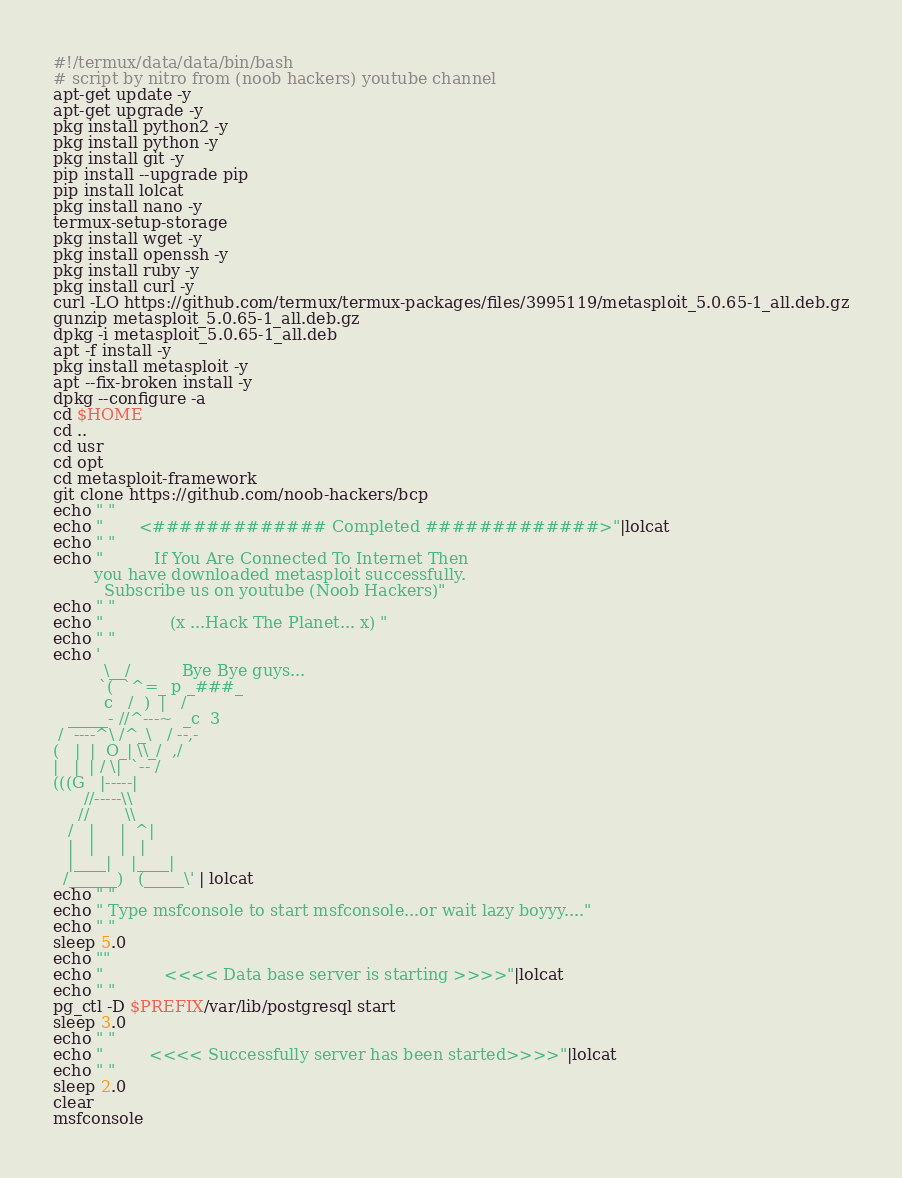<code> <loc_0><loc_0><loc_500><loc_500><_Bash_>#!/termux/data/data/bin/bash
# script by nitro from (noob hackers) youtube channel
apt-get update -y
apt-get upgrade -y
pkg install python2 -y
pkg install python -y
pkg install git -y
pip install --upgrade pip
pip install lolcat 
pkg install nano -y
termux-setup-storage
pkg install wget -y
pkg install openssh -y
pkg install ruby -y
pkg install curl -y
curl -LO https://github.com/termux/termux-packages/files/3995119/metasploit_5.0.65-1_all.deb.gz
gunzip metasploit_5.0.65-1_all.deb.gz
dpkg -i metasploit_5.0.65-1_all.deb 
apt -f install -y
pkg install metasploit -y
apt --fix-broken install -y
dpkg --configure -a
cd $HOME
cd ..
cd usr
cd opt
cd metasploit-framework
git clone https://github.com/noob-hackers/bcp
echo " "
echo "       <############# Completed #############>"|lolcat
echo " "
echo "          If You Are Connected To Internet Then
        you have downloaded metasploit successfully.
          Subscribe us on youtube (Noob Hackers)"
echo " "
echo "             (x ...Hack The Planet... x) "
echo " "
echo '
          \__/          Bye Bye guys...
         `(  `^=_ p _###_
          c   /  )  |   /
   _____- //^---~  _c  3
 /  ----^\ /^_\   / --,-
(   |  |  O_| \\_/  ,/
|   |  | / \|  `-- /
(((G   |-----|
      //-----\\
     //       \\
   /   |     |  ^|
   |   |     |   |
   |____|    |____|
  /______)   (_____\' | lolcat
echo " "
echo " Type msfconsole to start msfconsole...or wait lazy boyyy...."
echo " "
sleep 5.0
echo ""
echo "            <<<< Data base server is starting >>>>"|lolcat
echo " "
pg_ctl -D $PREFIX/var/lib/postgresql start
sleep 3.0
echo " "
echo "         <<<< Successfully server has been started>>>>"|lolcat
echo " "
sleep 2.0
clear
msfconsole
</code> 